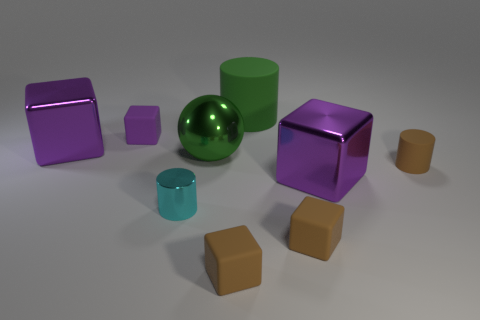Subtract all big metal blocks. How many blocks are left? 3 Subtract all yellow balls. How many brown blocks are left? 2 Add 1 large shiny objects. How many objects exist? 10 Subtract all brown blocks. How many blocks are left? 3 Subtract 4 cubes. How many cubes are left? 1 Subtract all spheres. How many objects are left? 8 Add 5 cyan metal cylinders. How many cyan metal cylinders are left? 6 Add 1 brown matte cylinders. How many brown matte cylinders exist? 2 Subtract 0 gray cylinders. How many objects are left? 9 Subtract all cyan cylinders. Subtract all cyan balls. How many cylinders are left? 2 